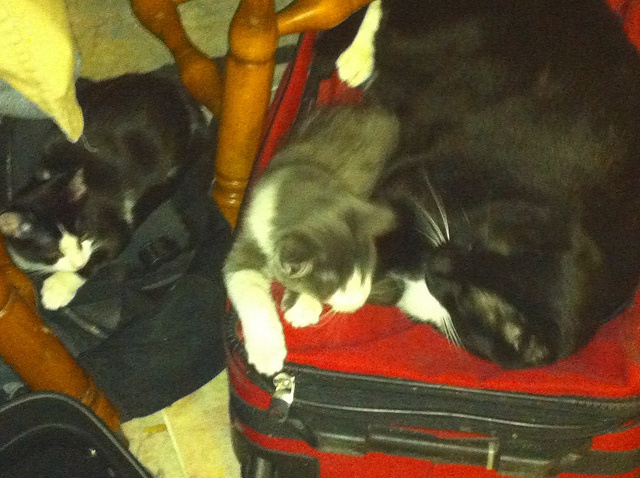Describe the objects in this image and their specific colors. I can see cat in yellow, black, darkgreen, and khaki tones, suitcase in khaki, darkgreen, brown, red, and black tones, cat in yellow, olive, and lightyellow tones, cat in khaki, black, darkgreen, and gray tones, and chair in yellow, olive, maroon, and orange tones in this image. 